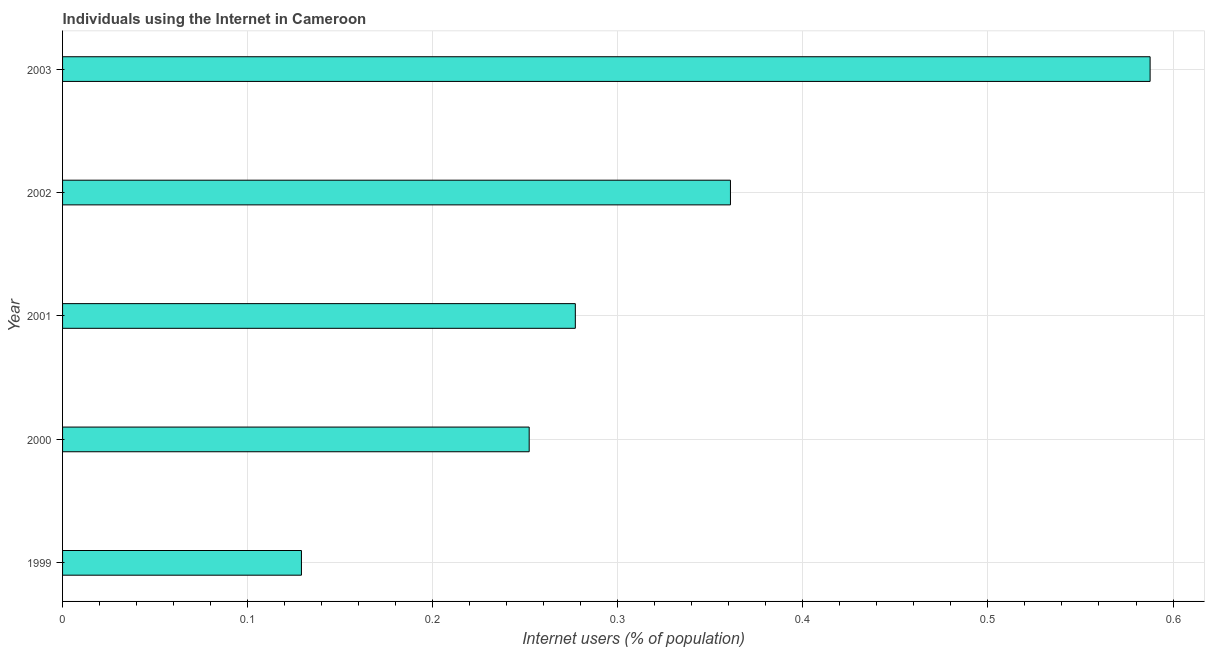Does the graph contain any zero values?
Provide a succinct answer. No. What is the title of the graph?
Give a very brief answer. Individuals using the Internet in Cameroon. What is the label or title of the X-axis?
Ensure brevity in your answer.  Internet users (% of population). What is the label or title of the Y-axis?
Offer a very short reply. Year. What is the number of internet users in 2002?
Ensure brevity in your answer.  0.36. Across all years, what is the maximum number of internet users?
Offer a very short reply. 0.59. Across all years, what is the minimum number of internet users?
Make the answer very short. 0.13. What is the sum of the number of internet users?
Keep it short and to the point. 1.61. What is the difference between the number of internet users in 1999 and 2001?
Your answer should be very brief. -0.15. What is the average number of internet users per year?
Keep it short and to the point. 0.32. What is the median number of internet users?
Your answer should be compact. 0.28. In how many years, is the number of internet users greater than 0.34 %?
Keep it short and to the point. 2. What is the ratio of the number of internet users in 1999 to that in 2001?
Provide a succinct answer. 0.47. Is the difference between the number of internet users in 2000 and 2002 greater than the difference between any two years?
Give a very brief answer. No. What is the difference between the highest and the second highest number of internet users?
Ensure brevity in your answer.  0.23. What is the difference between the highest and the lowest number of internet users?
Provide a short and direct response. 0.46. In how many years, is the number of internet users greater than the average number of internet users taken over all years?
Give a very brief answer. 2. How many bars are there?
Make the answer very short. 5. Are all the bars in the graph horizontal?
Offer a terse response. Yes. How many years are there in the graph?
Provide a succinct answer. 5. What is the difference between two consecutive major ticks on the X-axis?
Ensure brevity in your answer.  0.1. What is the Internet users (% of population) in 1999?
Your answer should be compact. 0.13. What is the Internet users (% of population) of 2000?
Offer a very short reply. 0.25. What is the Internet users (% of population) in 2001?
Provide a short and direct response. 0.28. What is the Internet users (% of population) of 2002?
Offer a very short reply. 0.36. What is the Internet users (% of population) in 2003?
Ensure brevity in your answer.  0.59. What is the difference between the Internet users (% of population) in 1999 and 2000?
Your answer should be compact. -0.12. What is the difference between the Internet users (% of population) in 1999 and 2001?
Offer a terse response. -0.15. What is the difference between the Internet users (% of population) in 1999 and 2002?
Your response must be concise. -0.23. What is the difference between the Internet users (% of population) in 1999 and 2003?
Your answer should be compact. -0.46. What is the difference between the Internet users (% of population) in 2000 and 2001?
Make the answer very short. -0.02. What is the difference between the Internet users (% of population) in 2000 and 2002?
Your response must be concise. -0.11. What is the difference between the Internet users (% of population) in 2000 and 2003?
Provide a short and direct response. -0.34. What is the difference between the Internet users (% of population) in 2001 and 2002?
Keep it short and to the point. -0.08. What is the difference between the Internet users (% of population) in 2001 and 2003?
Keep it short and to the point. -0.31. What is the difference between the Internet users (% of population) in 2002 and 2003?
Offer a terse response. -0.23. What is the ratio of the Internet users (% of population) in 1999 to that in 2000?
Give a very brief answer. 0.51. What is the ratio of the Internet users (% of population) in 1999 to that in 2001?
Offer a very short reply. 0.47. What is the ratio of the Internet users (% of population) in 1999 to that in 2002?
Your answer should be compact. 0.36. What is the ratio of the Internet users (% of population) in 1999 to that in 2003?
Provide a succinct answer. 0.22. What is the ratio of the Internet users (% of population) in 2000 to that in 2001?
Offer a terse response. 0.91. What is the ratio of the Internet users (% of population) in 2000 to that in 2002?
Your answer should be very brief. 0.7. What is the ratio of the Internet users (% of population) in 2000 to that in 2003?
Offer a very short reply. 0.43. What is the ratio of the Internet users (% of population) in 2001 to that in 2002?
Give a very brief answer. 0.77. What is the ratio of the Internet users (% of population) in 2001 to that in 2003?
Provide a short and direct response. 0.47. What is the ratio of the Internet users (% of population) in 2002 to that in 2003?
Ensure brevity in your answer.  0.61. 